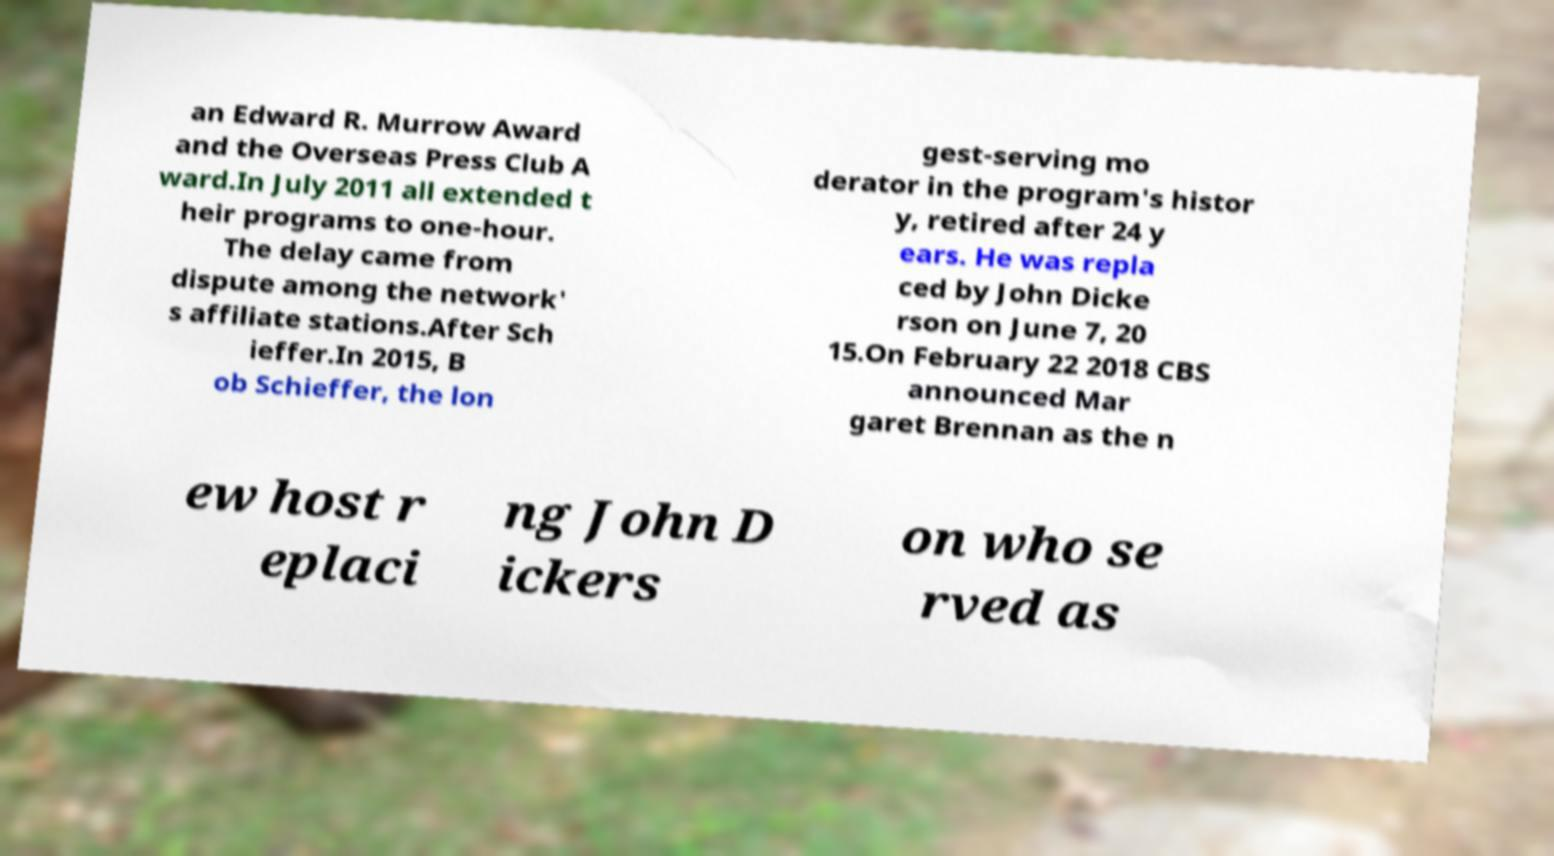Can you read and provide the text displayed in the image?This photo seems to have some interesting text. Can you extract and type it out for me? an Edward R. Murrow Award and the Overseas Press Club A ward.In July 2011 all extended t heir programs to one-hour. The delay came from dispute among the network' s affiliate stations.After Sch ieffer.In 2015, B ob Schieffer, the lon gest-serving mo derator in the program's histor y, retired after 24 y ears. He was repla ced by John Dicke rson on June 7, 20 15.On February 22 2018 CBS announced Mar garet Brennan as the n ew host r eplaci ng John D ickers on who se rved as 